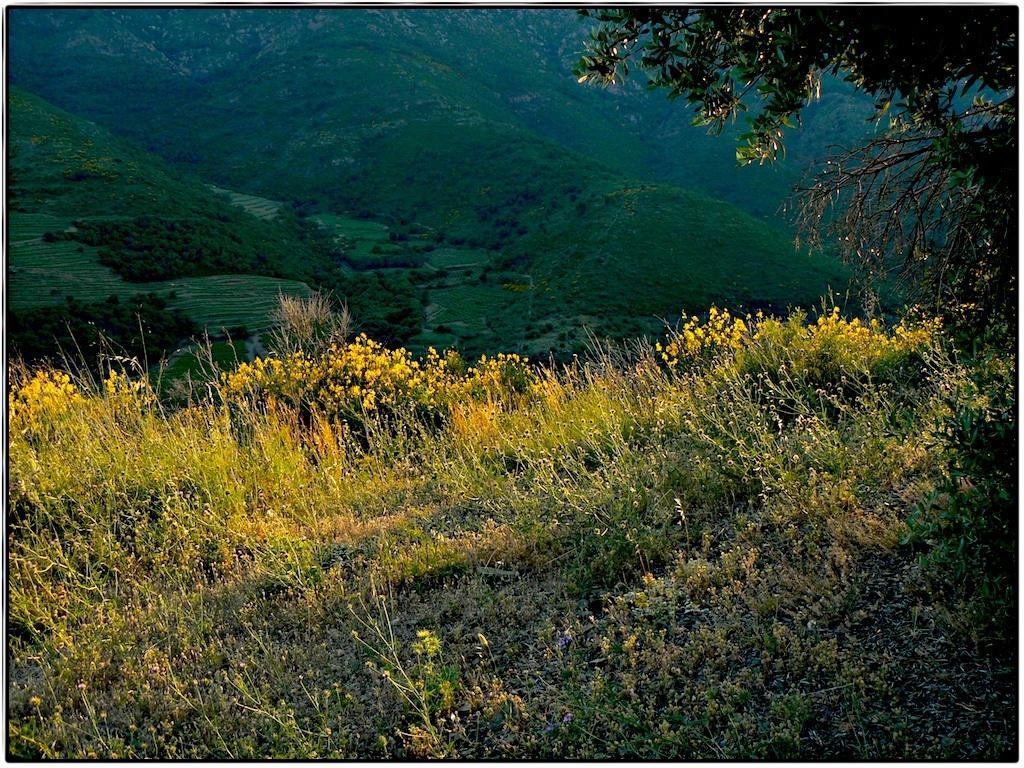How would you summarize this image in a sentence or two? In the foreground of the image we can see group of plants. In the background, we can see a tree and mountains. 